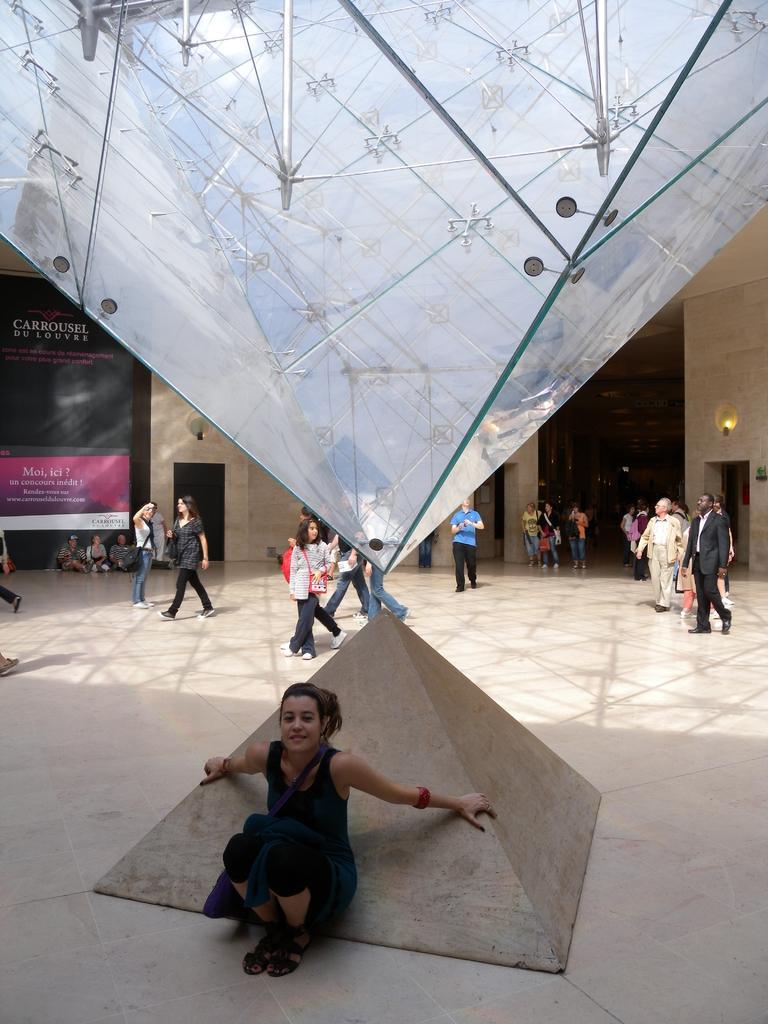In one or two sentences, can you explain what this image depicts? At the bottom there is a woman who is wearing black dress. She is sitting near to the pyramid. In the background we can see the group of persons were standing near the wall. On the left background there is a group of person sitting near to the banner and door. On the right we can see the group of persons were standing near to the door. 